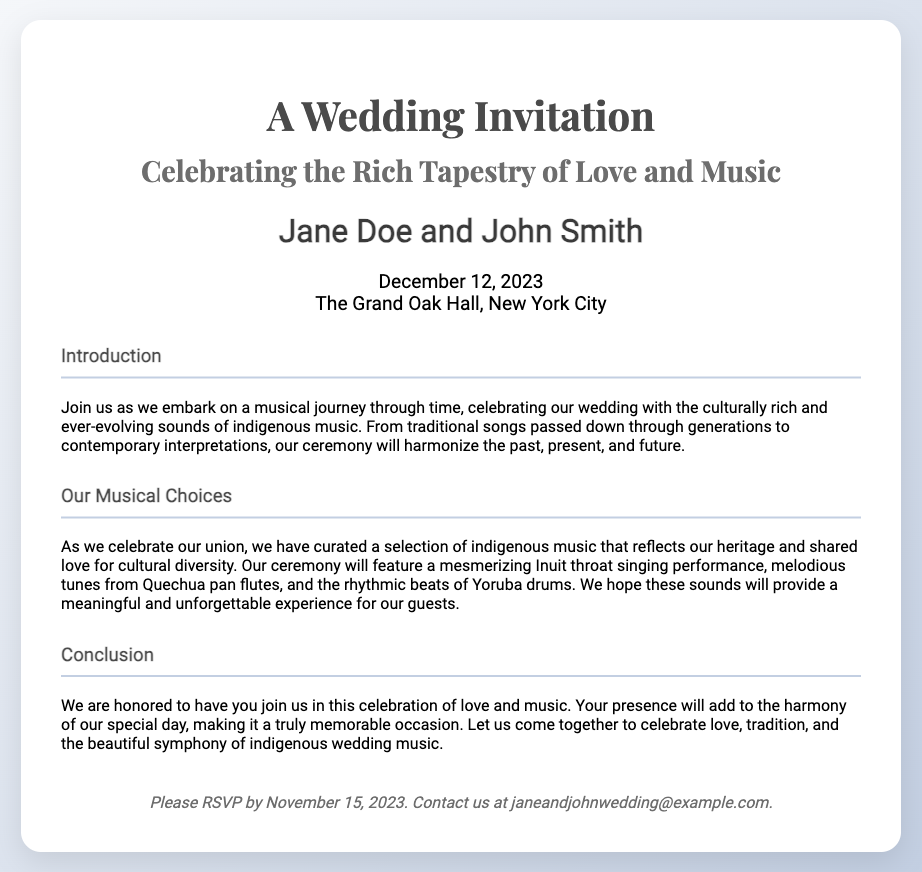What are the names of the couple? The document states the names of the couple are "Jane Doe and John Smith."
Answer: Jane Doe and John Smith What is the wedding date? The document specifies that the wedding will take place on "December 12, 2023."
Answer: December 12, 2023 Where is the wedding venue? The venue for the wedding is listed as "The Grand Oak Hall, New York City."
Answer: The Grand Oak Hall, New York City What type of music will be featured in the ceremony? The document mentions that the ceremony will showcase "indigenous music."
Answer: Indigenous music When should guests RSVP by? The RSVP deadline is provided as "November 15, 2023."
Answer: November 15, 2023 What musical performance from the Inuit culture will be included? The document mentions an "Inuit throat singing performance."
Answer: Inuit throat singing performance What do the couple hope their guests will experience? The couple expresses a hope for guests to have a "meaningful and unforgettable experience."
Answer: Meaningful and unforgettable experience What is the theme of the wedding invitation? The theme is indicated as "Celebrating the Rich Tapestry of Love and Music."
Answer: Celebrating the Rich Tapestry of Love and Music What is the purpose of the wedding invitation? The primary purpose is to invite guests to join in the celebration of their wedding, as stated in the introduction.
Answer: To invite guests to the wedding 